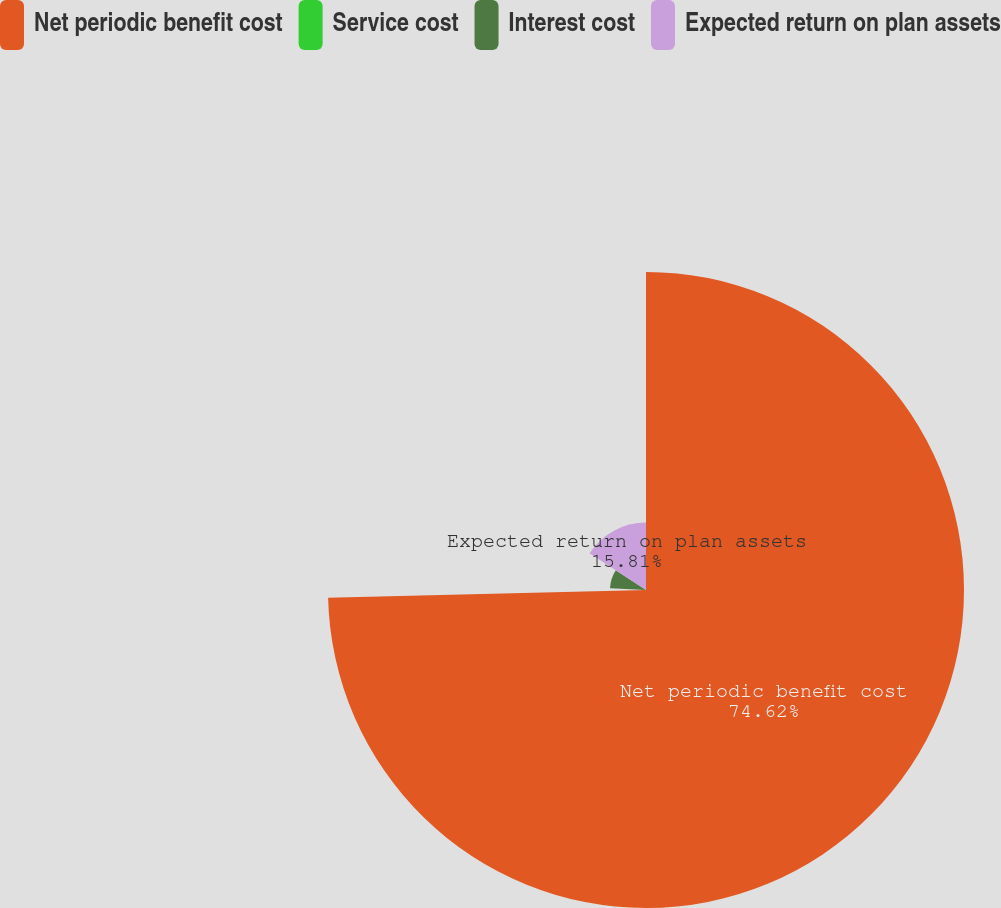Convert chart. <chart><loc_0><loc_0><loc_500><loc_500><pie_chart><fcel>Net periodic benefit cost<fcel>Service cost<fcel>Interest cost<fcel>Expected return on plan assets<nl><fcel>74.61%<fcel>1.11%<fcel>8.46%<fcel>15.81%<nl></chart> 